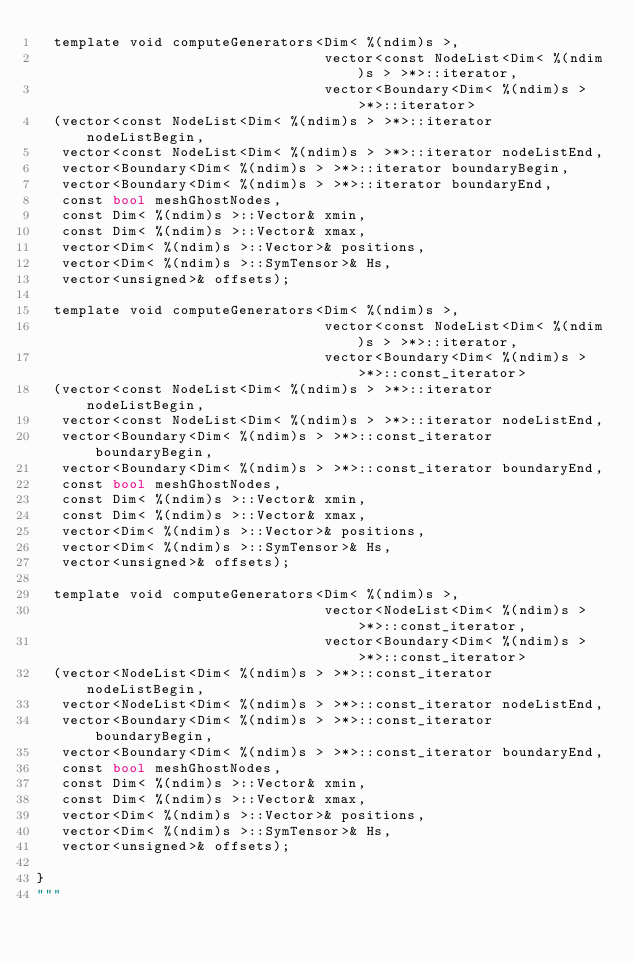<code> <loc_0><loc_0><loc_500><loc_500><_Python_>  template void computeGenerators<Dim< %(ndim)s >, 
                                  vector<const NodeList<Dim< %(ndim)s > >*>::iterator,
                                  vector<Boundary<Dim< %(ndim)s > >*>::iterator>
  (vector<const NodeList<Dim< %(ndim)s > >*>::iterator nodeListBegin,
   vector<const NodeList<Dim< %(ndim)s > >*>::iterator nodeListEnd,
   vector<Boundary<Dim< %(ndim)s > >*>::iterator boundaryBegin,
   vector<Boundary<Dim< %(ndim)s > >*>::iterator boundaryEnd,
   const bool meshGhostNodes,
   const Dim< %(ndim)s >::Vector& xmin,
   const Dim< %(ndim)s >::Vector& xmax,
   vector<Dim< %(ndim)s >::Vector>& positions,
   vector<Dim< %(ndim)s >::SymTensor>& Hs,
   vector<unsigned>& offsets);

  template void computeGenerators<Dim< %(ndim)s >, 
                                  vector<const NodeList<Dim< %(ndim)s > >*>::iterator,
                                  vector<Boundary<Dim< %(ndim)s > >*>::const_iterator>
  (vector<const NodeList<Dim< %(ndim)s > >*>::iterator nodeListBegin,
   vector<const NodeList<Dim< %(ndim)s > >*>::iterator nodeListEnd,
   vector<Boundary<Dim< %(ndim)s > >*>::const_iterator boundaryBegin,
   vector<Boundary<Dim< %(ndim)s > >*>::const_iterator boundaryEnd,
   const bool meshGhostNodes,
   const Dim< %(ndim)s >::Vector& xmin,
   const Dim< %(ndim)s >::Vector& xmax,
   vector<Dim< %(ndim)s >::Vector>& positions,
   vector<Dim< %(ndim)s >::SymTensor>& Hs,
   vector<unsigned>& offsets);

  template void computeGenerators<Dim< %(ndim)s >, 
                                  vector<NodeList<Dim< %(ndim)s > >*>::const_iterator,
                                  vector<Boundary<Dim< %(ndim)s > >*>::const_iterator>
  (vector<NodeList<Dim< %(ndim)s > >*>::const_iterator nodeListBegin,
   vector<NodeList<Dim< %(ndim)s > >*>::const_iterator nodeListEnd,
   vector<Boundary<Dim< %(ndim)s > >*>::const_iterator boundaryBegin,
   vector<Boundary<Dim< %(ndim)s > >*>::const_iterator boundaryEnd,
   const bool meshGhostNodes,
   const Dim< %(ndim)s >::Vector& xmin,
   const Dim< %(ndim)s >::Vector& xmax,
   vector<Dim< %(ndim)s >::Vector>& positions,
   vector<Dim< %(ndim)s >::SymTensor>& Hs,
   vector<unsigned>& offsets);

}
"""
</code> 